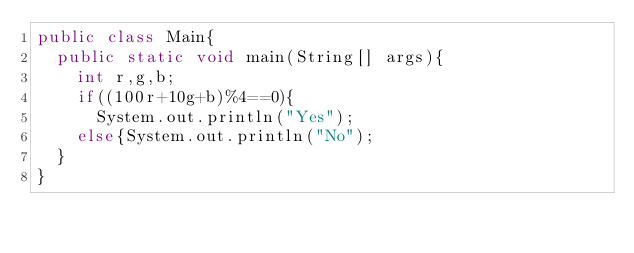Convert code to text. <code><loc_0><loc_0><loc_500><loc_500><_Java_>public class Main{
  public static void main(String[] args){
    int r,g,b;
    if((100r+10g+b)%4==0){
      System.out.println("Yes");
    else{System.out.println("No");
  }
}
</code> 